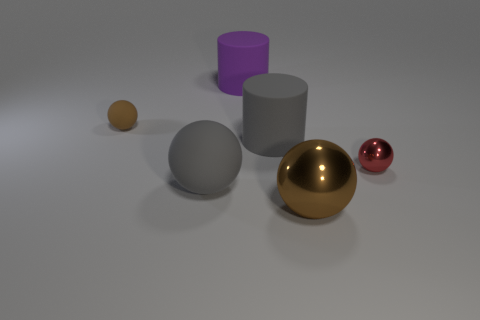Subtract all big rubber balls. How many balls are left? 3 Subtract all yellow cylinders. How many brown balls are left? 2 Subtract all red spheres. How many spheres are left? 3 Add 1 small green rubber balls. How many objects exist? 7 Subtract all cylinders. How many objects are left? 4 Add 5 small shiny things. How many small shiny things are left? 6 Add 4 small shiny things. How many small shiny things exist? 5 Subtract 0 green spheres. How many objects are left? 6 Subtract all brown cylinders. Subtract all blue spheres. How many cylinders are left? 2 Subtract all red metallic balls. Subtract all big brown shiny balls. How many objects are left? 4 